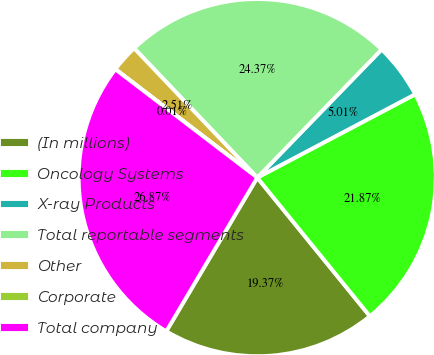Convert chart to OTSL. <chart><loc_0><loc_0><loc_500><loc_500><pie_chart><fcel>(In millions)<fcel>Oncology Systems<fcel>X-ray Products<fcel>Total reportable segments<fcel>Other<fcel>Corporate<fcel>Total company<nl><fcel>19.37%<fcel>21.87%<fcel>5.01%<fcel>24.37%<fcel>2.51%<fcel>0.01%<fcel>26.87%<nl></chart> 